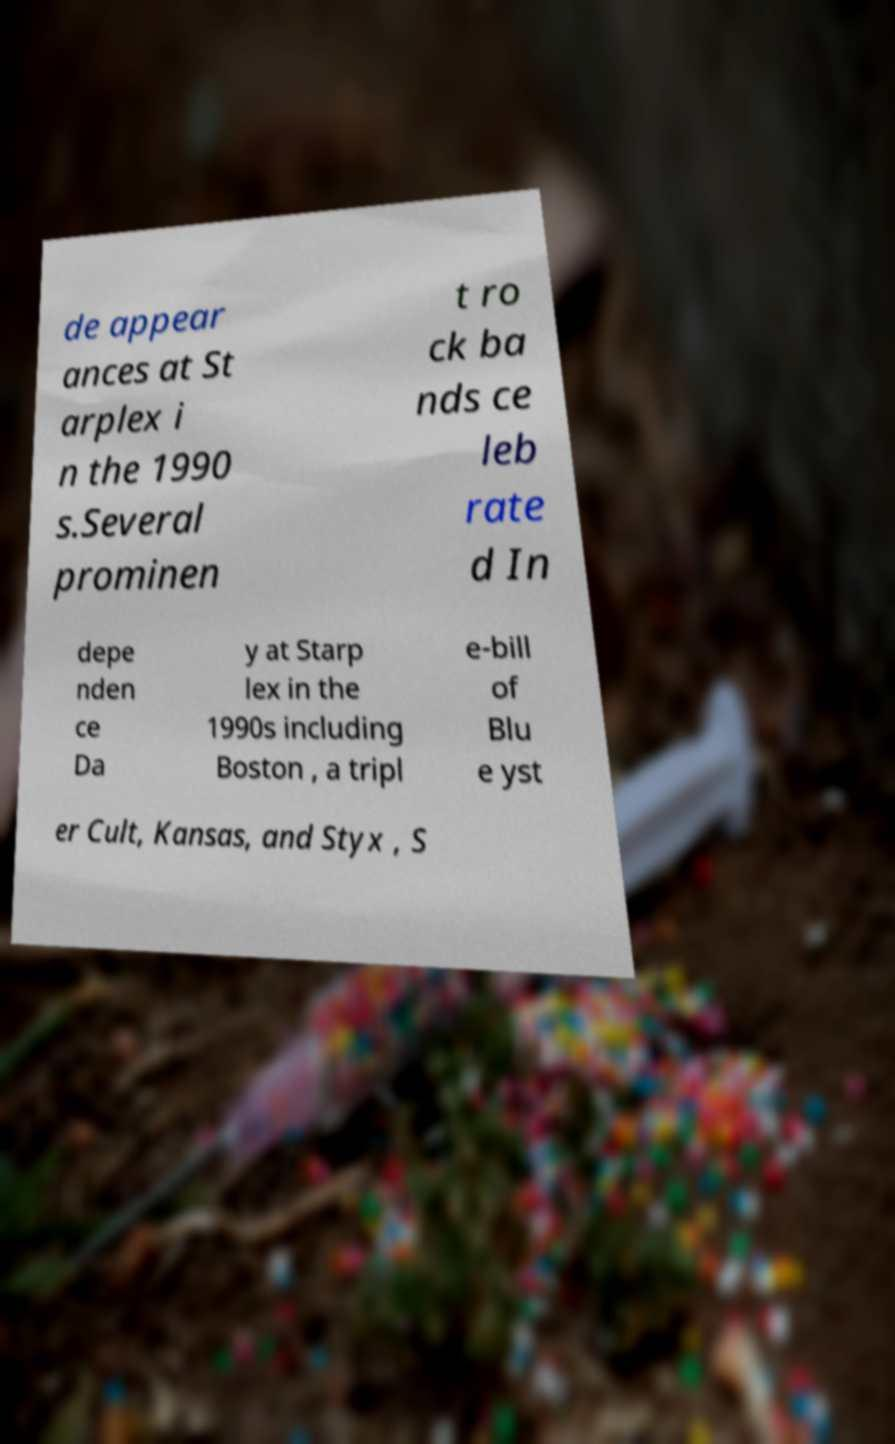What messages or text are displayed in this image? I need them in a readable, typed format. de appear ances at St arplex i n the 1990 s.Several prominen t ro ck ba nds ce leb rate d In depe nden ce Da y at Starp lex in the 1990s including Boston , a tripl e-bill of Blu e yst er Cult, Kansas, and Styx , S 